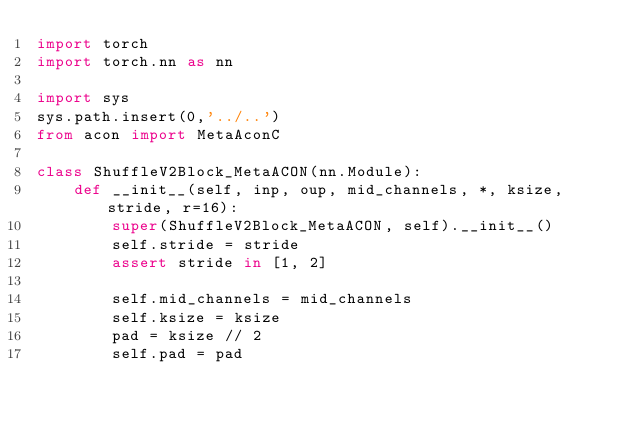Convert code to text. <code><loc_0><loc_0><loc_500><loc_500><_Python_>import torch
import torch.nn as nn

import sys
sys.path.insert(0,'../..')
from acon import MetaAconC

class ShuffleV2Block_MetaACON(nn.Module):
    def __init__(self, inp, oup, mid_channels, *, ksize, stride, r=16):
        super(ShuffleV2Block_MetaACON, self).__init__()
        self.stride = stride
        assert stride in [1, 2]

        self.mid_channels = mid_channels
        self.ksize = ksize
        pad = ksize // 2
        self.pad = pad</code> 